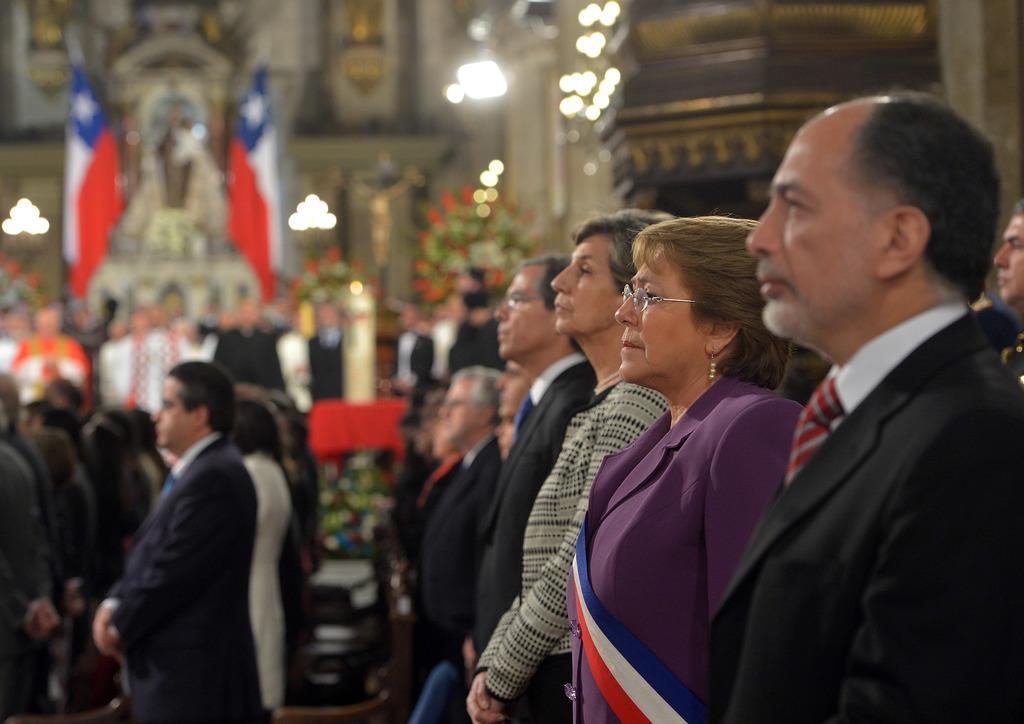Could you give a brief overview of what you see in this image? In this image I can see group of people standing. In front the person is wearing black color blazer, white color shirt. In the background I can see few flags and few lights. 